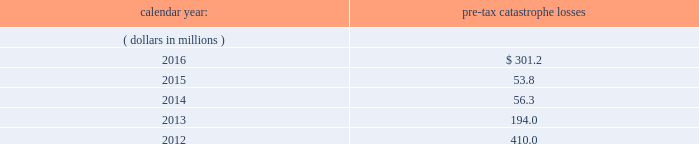Risks relating to our business fluctuations in the financial markets could result in investment losses .
Prolonged and severe disruptions in the overall public debt and equity markets , such as occurred during 2008 , could result in significant realized and unrealized losses in our investment portfolio .
Although financial markets have significantly improved since 2008 , they could deteriorate in the future .
There could also be disruption in individual market sectors , such as occurred in the energy sector in recent years .
Such declines in the financial markets could result in significant realized and unrealized losses on investments and could have a material adverse impact on our results of operations , equity , business and insurer financial strength and debt ratings .
Our results could be adversely affected by catastrophic events .
We are exposed to unpredictable catastrophic events , including weather-related and other natural catastrophes , as well as acts of terrorism .
Any material reduction in our operating results caused by the occurrence of one or more catastrophes could inhibit our ability to pay dividends or to meet our interest and principal payment obligations .
By way of illustration , during the past five calendar years , pre-tax catastrophe losses , net of contract specific reinsurance but before cessions under corporate reinsurance programs , were as follows: .
Our losses from future catastrophic events could exceed our projections .
We use projections of possible losses from future catastrophic events of varying types and magnitudes as a strategic underwriting tool .
We use these loss projections to estimate our potential catastrophe losses in certain geographic areas and decide on the placement of retrocessional coverage or other actions to limit the extent of potential losses in a given geographic area .
These loss projections are approximations , reliant on a mix of quantitative and qualitative processes , and actual losses may exceed the projections by a material amount , resulting in a material adverse effect on our financial condition and results of operations. .
What are the total pre-tax catastrophe losses in the last two years? 
Computations: (301.2 + 53.8)
Answer: 355.0. 